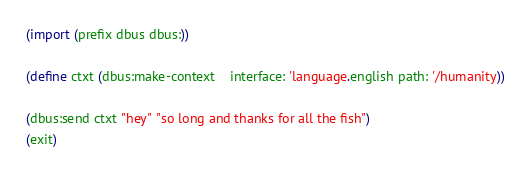<code> <loc_0><loc_0><loc_500><loc_500><_Scheme_>(import (prefix dbus dbus:))

(define ctxt (dbus:make-context	interface: 'language.english path: '/humanity))

(dbus:send ctxt "hey" "so long and thanks for all the fish")
(exit)
</code> 